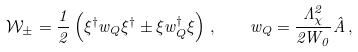Convert formula to latex. <formula><loc_0><loc_0><loc_500><loc_500>\mathcal { W } _ { \pm } = \frac { 1 } { 2 } \left ( \xi ^ { \dagger } w _ { Q } \xi ^ { \dagger } \pm \xi w _ { Q } ^ { \dagger } \xi \right ) \, , \quad w _ { Q } = \frac { \Lambda _ { \chi } ^ { 2 } } { 2 W _ { 0 } } \hat { A } \, ,</formula> 